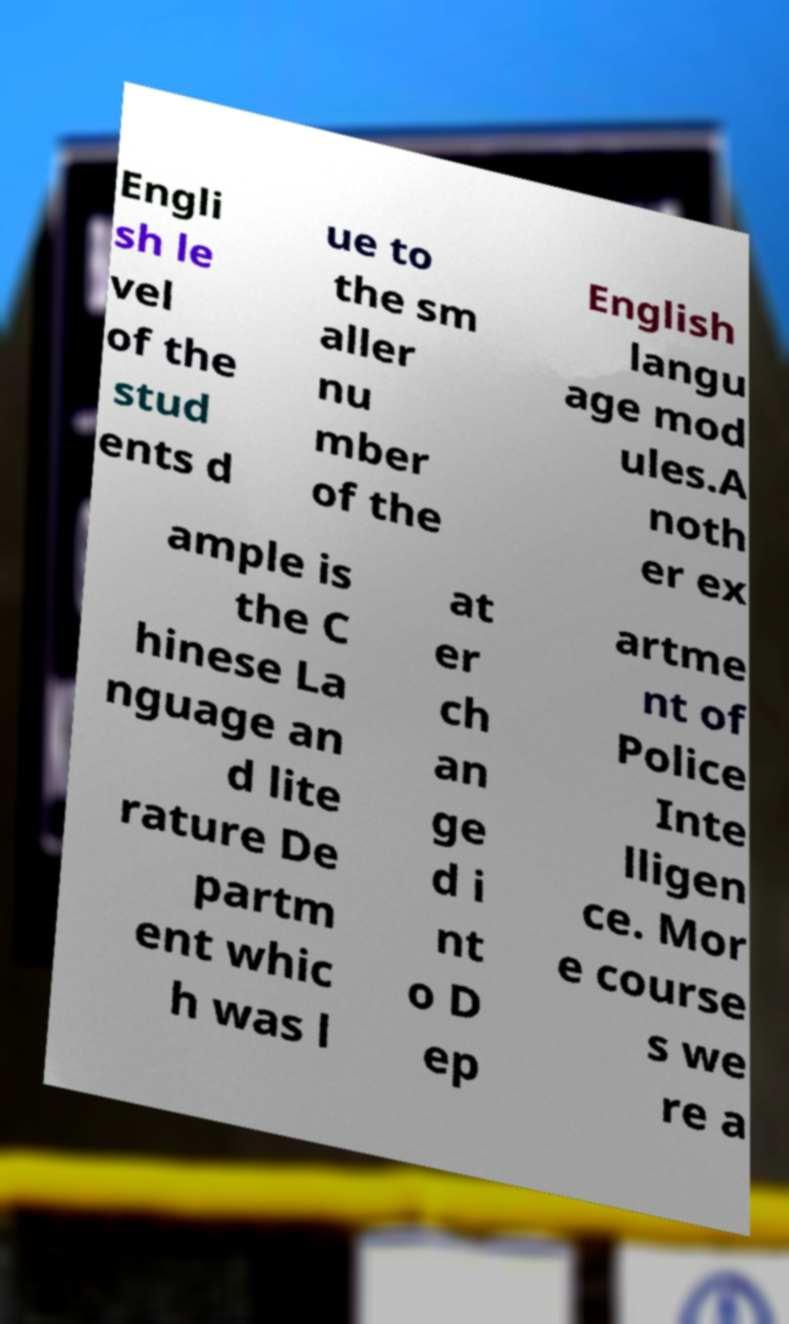Could you extract and type out the text from this image? Engli sh le vel of the stud ents d ue to the sm aller nu mber of the English langu age mod ules.A noth er ex ample is the C hinese La nguage an d lite rature De partm ent whic h was l at er ch an ge d i nt o D ep artme nt of Police Inte lligen ce. Mor e course s we re a 